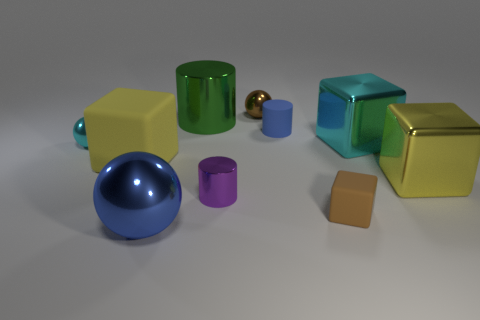Subtract all yellow cylinders. Subtract all red balls. How many cylinders are left? 3 Subtract all blocks. How many objects are left? 6 Add 7 tiny brown cubes. How many tiny brown cubes exist? 8 Subtract 1 cyan balls. How many objects are left? 9 Subtract all large blue objects. Subtract all large green matte balls. How many objects are left? 9 Add 7 yellow things. How many yellow things are left? 9 